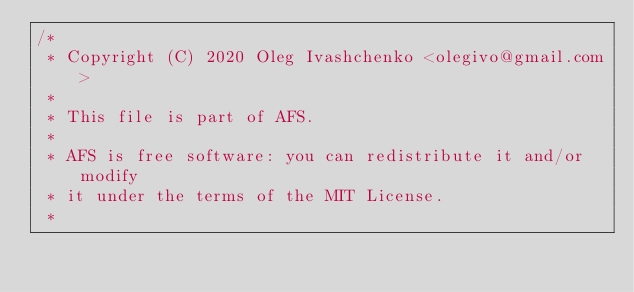<code> <loc_0><loc_0><loc_500><loc_500><_Kotlin_>/*
 * Copyright (C) 2020 Oleg Ivashchenko <olegivo@gmail.com>
 *
 * This file is part of AFS.
 *
 * AFS is free software: you can redistribute it and/or modify
 * it under the terms of the MIT License.
 *</code> 